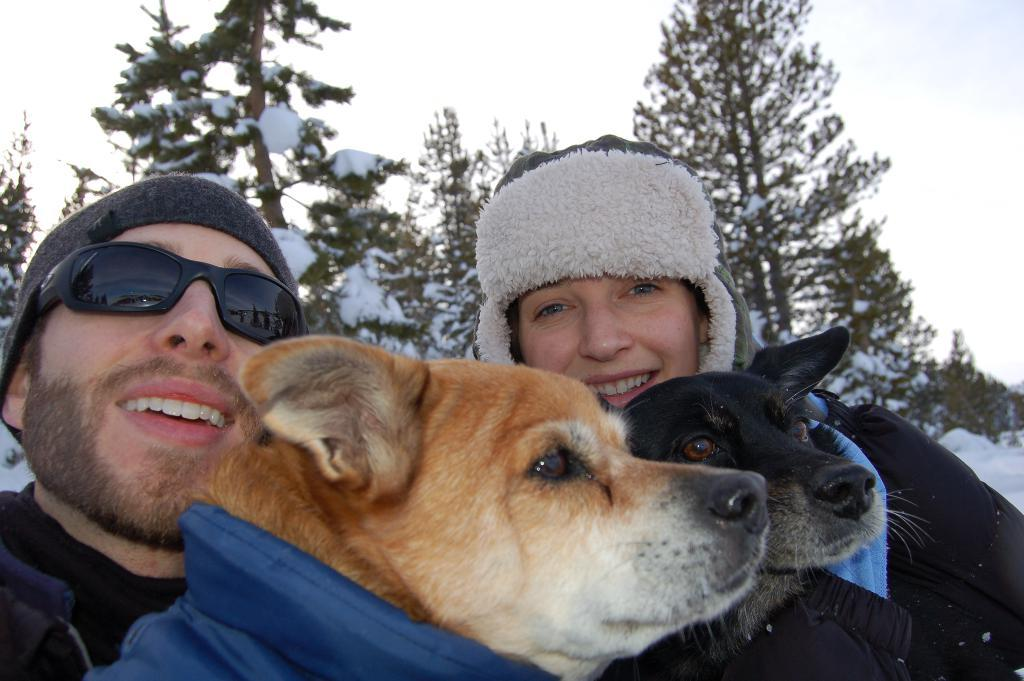How many people are in the image? There is a man and a woman in the image. What are the man and woman doing in the image? Both the man and woman are holding two dogs. Can you describe the dogs in the image? One dog is black, and the other dog has a mixed color of white and brown. What can be seen in the background of the image? There are trees in the background of the image, and snow is visible on top of the trees. How does the loss of taste affect the man and woman in the image? There is no mention of taste or loss of taste in the image, so this question cannot be answered definitively. 